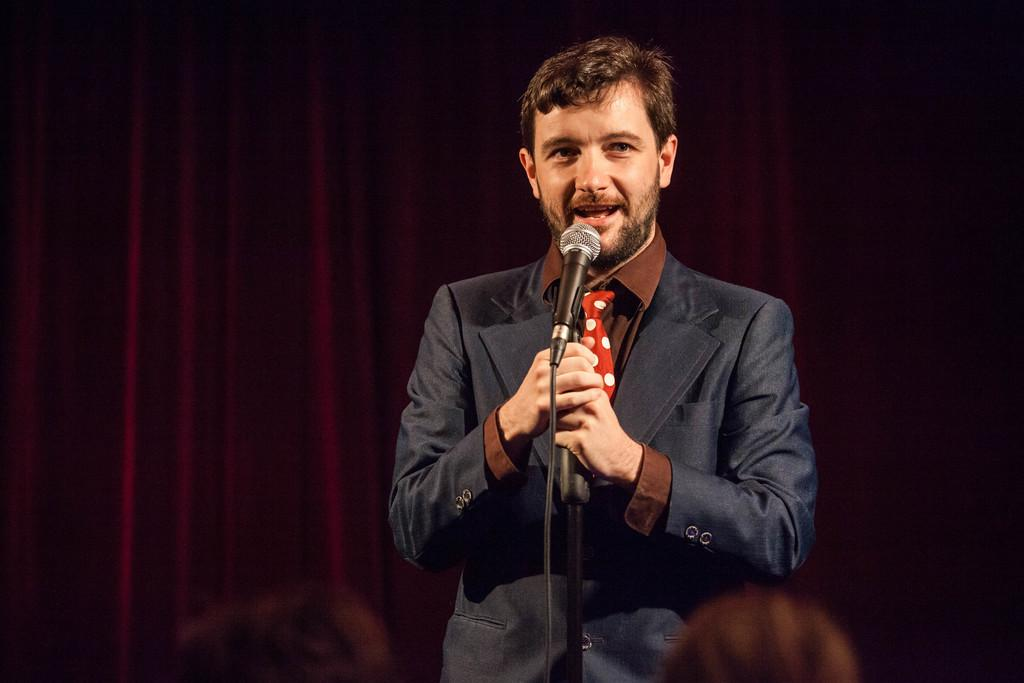Who is the main subject in the image? There is a man in the image. What is the man doing in the image? The man is standing in front of a microphone. Can you describe the man's attire in the image? The man is wearing a tie, a shirt, and a coat. What can be seen in the background of the image? There are curtains in the background of the image. What type of banana is the man holding in the image? There is no banana present in the image. Is the man driving a vehicle in the image? No, the man is not driving a vehicle in the image; he is standing in front of a microphone. 